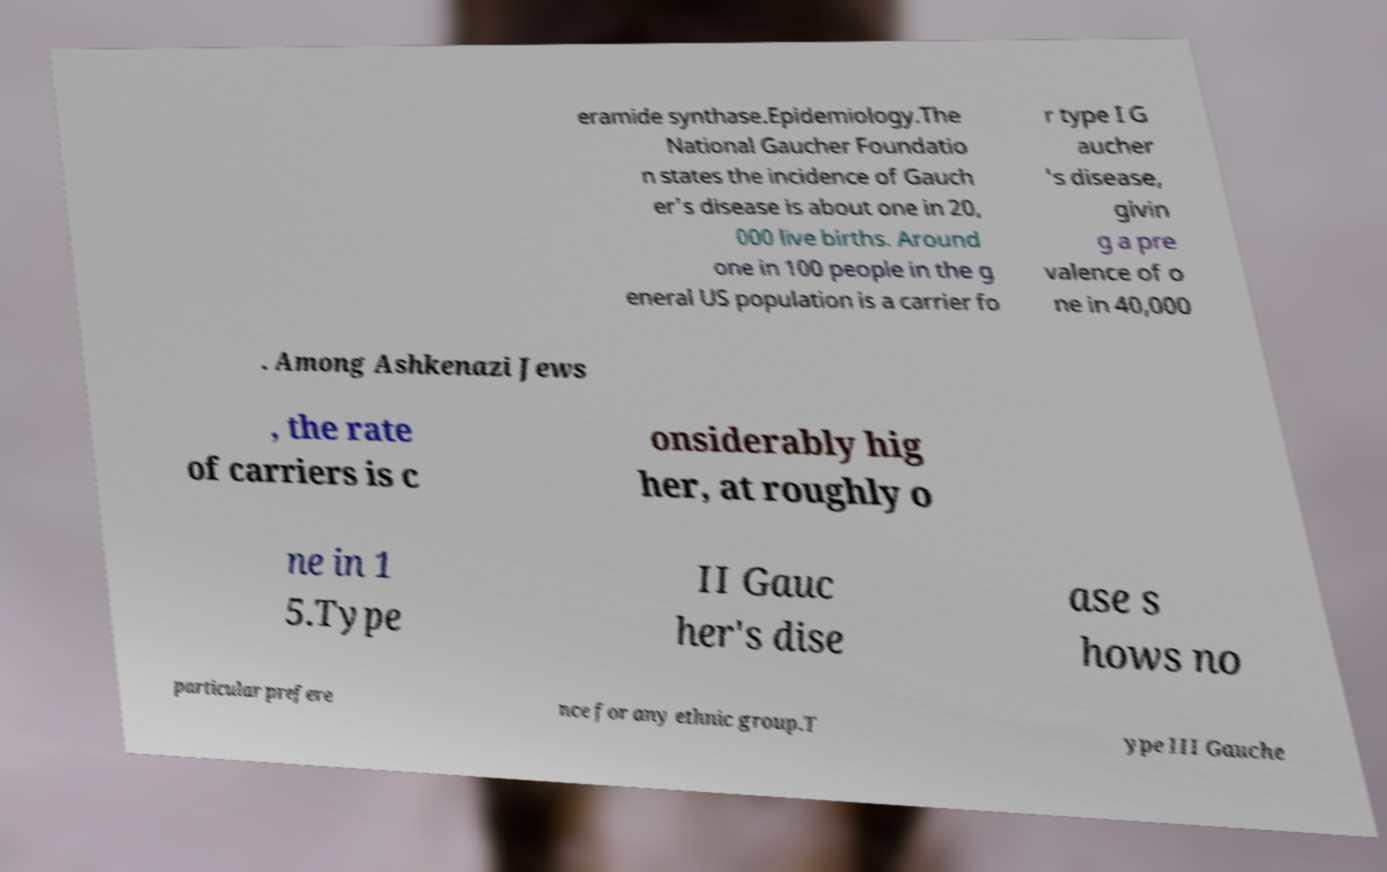I need the written content from this picture converted into text. Can you do that? eramide synthase.Epidemiology.The National Gaucher Foundatio n states the incidence of Gauch er's disease is about one in 20, 000 live births. Around one in 100 people in the g eneral US population is a carrier fo r type I G aucher 's disease, givin g a pre valence of o ne in 40,000 . Among Ashkenazi Jews , the rate of carriers is c onsiderably hig her, at roughly o ne in 1 5.Type II Gauc her's dise ase s hows no particular prefere nce for any ethnic group.T ype III Gauche 